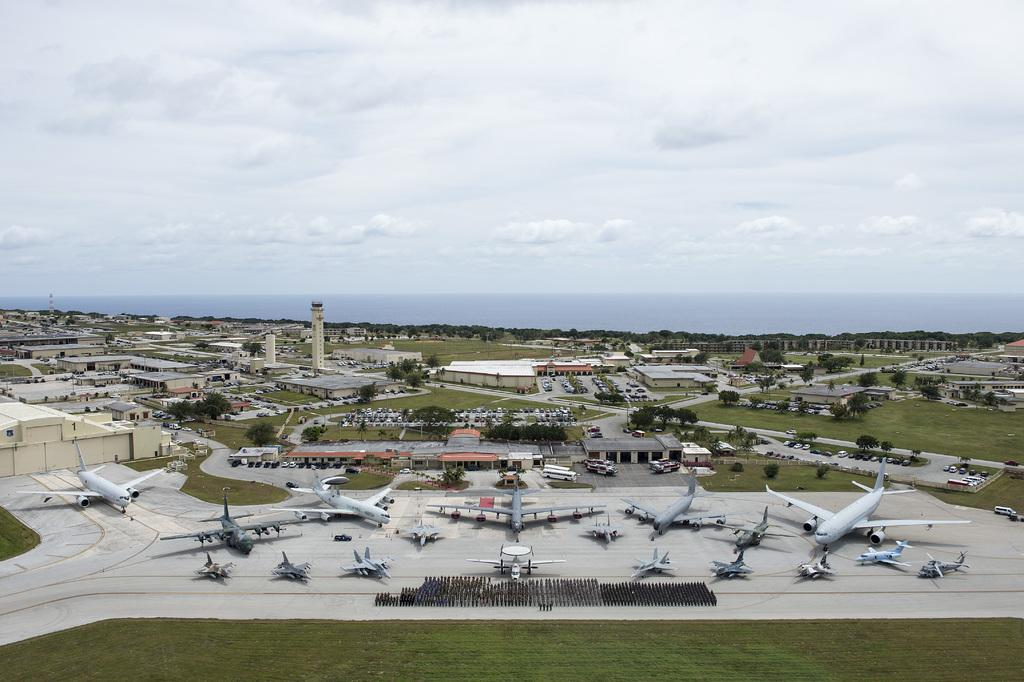What type of vegetation can be seen in the image? There is grass in the image. What type of transportation is present on the ground in the image? There are airplanes on the ground in the image. What other types of vehicles can be seen in the image? There are vehicles in the image. What type of natural structures are present in the image? There are trees in the image. What type of man-made structures are present in the image? There are buildings and a tower in the image. What else can be seen in the image besides the structures and vehicles? There are objects in the image. What is visible in the background of the image? The sky is visible in the background of the image. What can be seen in the sky? There are clouds in the sky. Where is the hydrant located in the image? There is no hydrant present in the image. What type of furniture can be seen in the image? There is no furniture, such as a sofa, present in the image. 